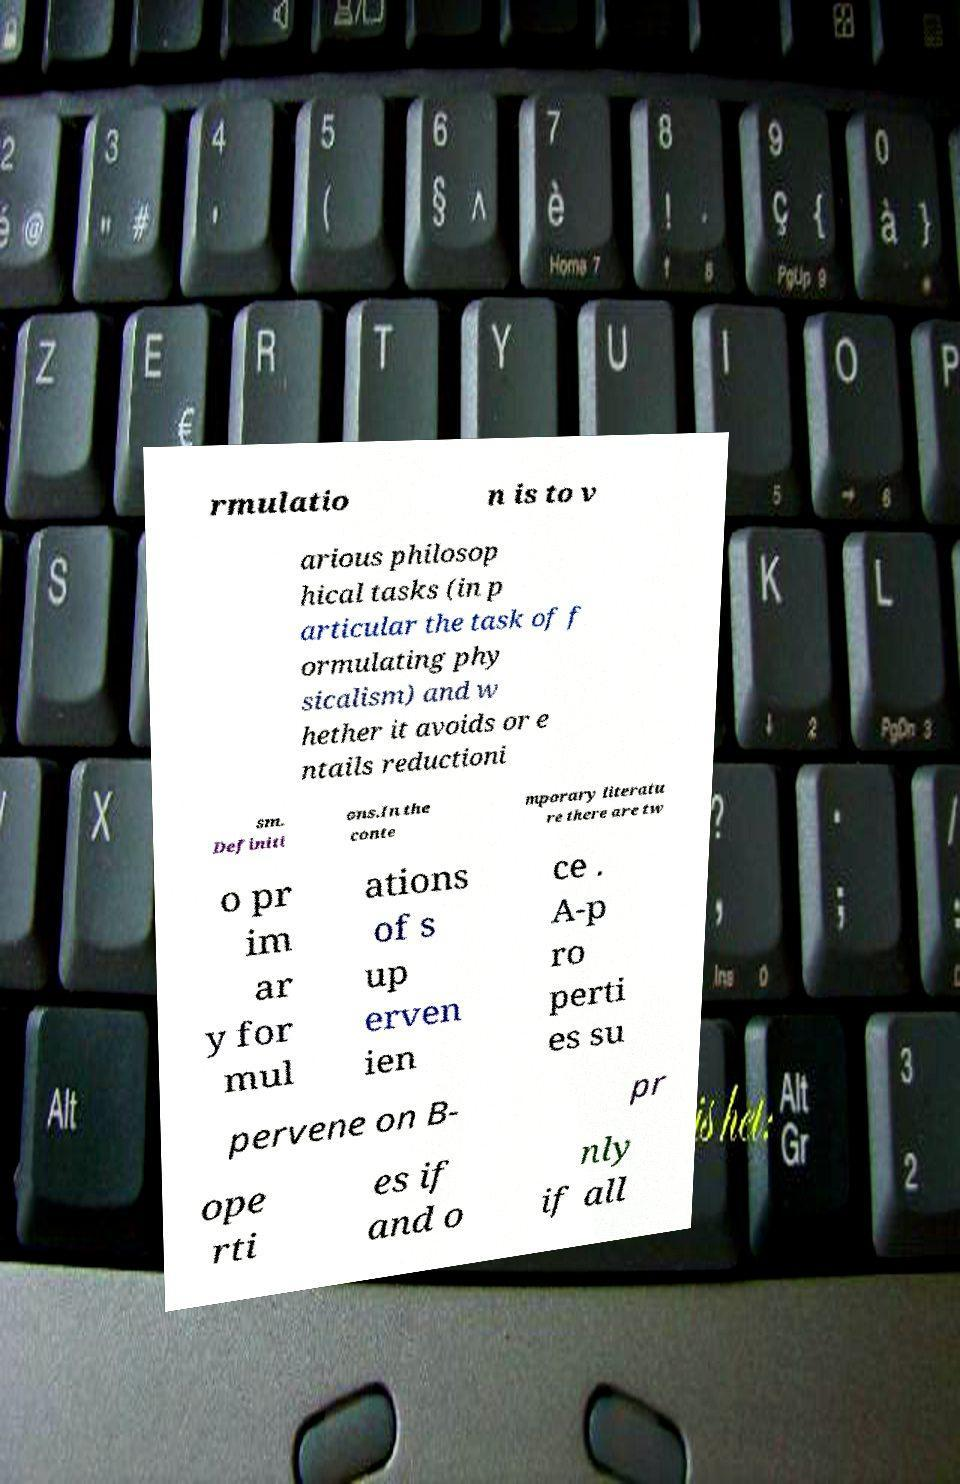Please read and relay the text visible in this image. What does it say? rmulatio n is to v arious philosop hical tasks (in p articular the task of f ormulating phy sicalism) and w hether it avoids or e ntails reductioni sm. Definiti ons.In the conte mporary literatu re there are tw o pr im ar y for mul ations of s up erven ien ce . A-p ro perti es su pervene on B- pr ope rti es if and o nly if all 